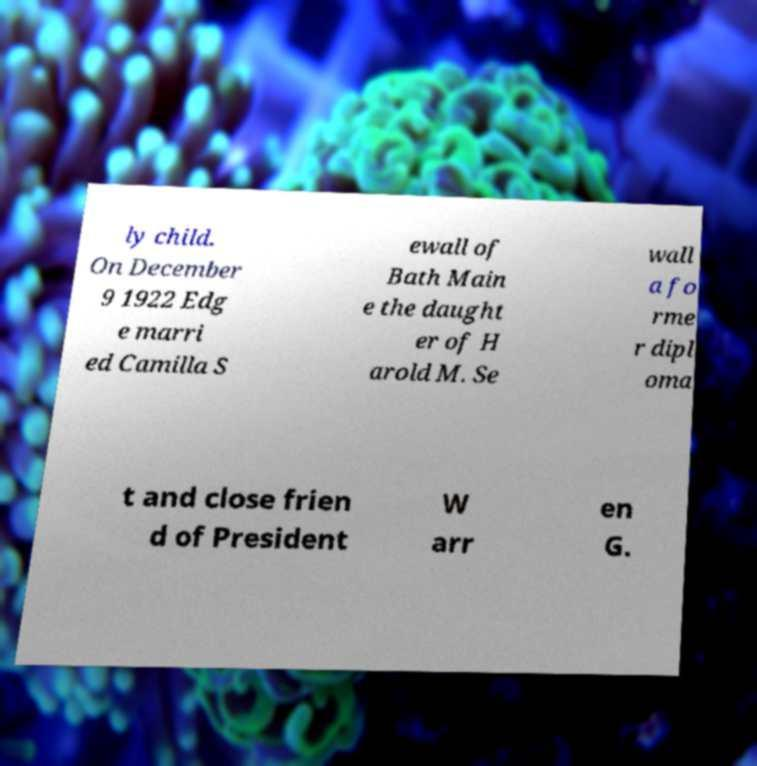What messages or text are displayed in this image? I need them in a readable, typed format. ly child. On December 9 1922 Edg e marri ed Camilla S ewall of Bath Main e the daught er of H arold M. Se wall a fo rme r dipl oma t and close frien d of President W arr en G. 